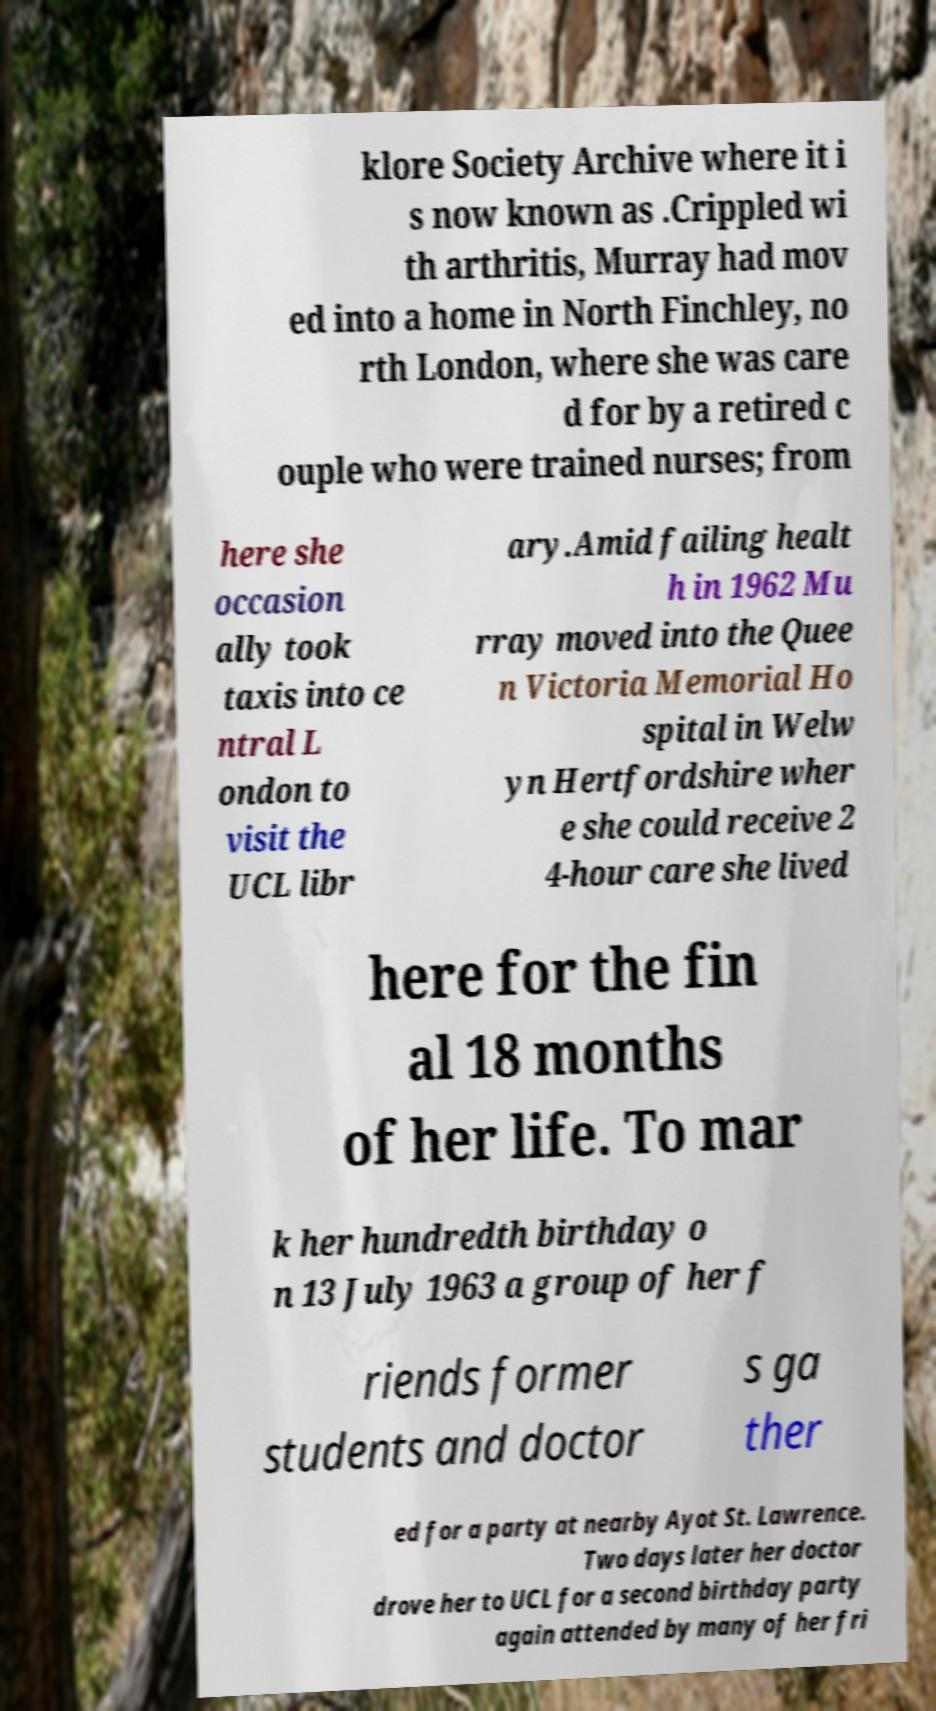Can you accurately transcribe the text from the provided image for me? klore Society Archive where it i s now known as .Crippled wi th arthritis, Murray had mov ed into a home in North Finchley, no rth London, where she was care d for by a retired c ouple who were trained nurses; from here she occasion ally took taxis into ce ntral L ondon to visit the UCL libr ary.Amid failing healt h in 1962 Mu rray moved into the Quee n Victoria Memorial Ho spital in Welw yn Hertfordshire wher e she could receive 2 4-hour care she lived here for the fin al 18 months of her life. To mar k her hundredth birthday o n 13 July 1963 a group of her f riends former students and doctor s ga ther ed for a party at nearby Ayot St. Lawrence. Two days later her doctor drove her to UCL for a second birthday party again attended by many of her fri 